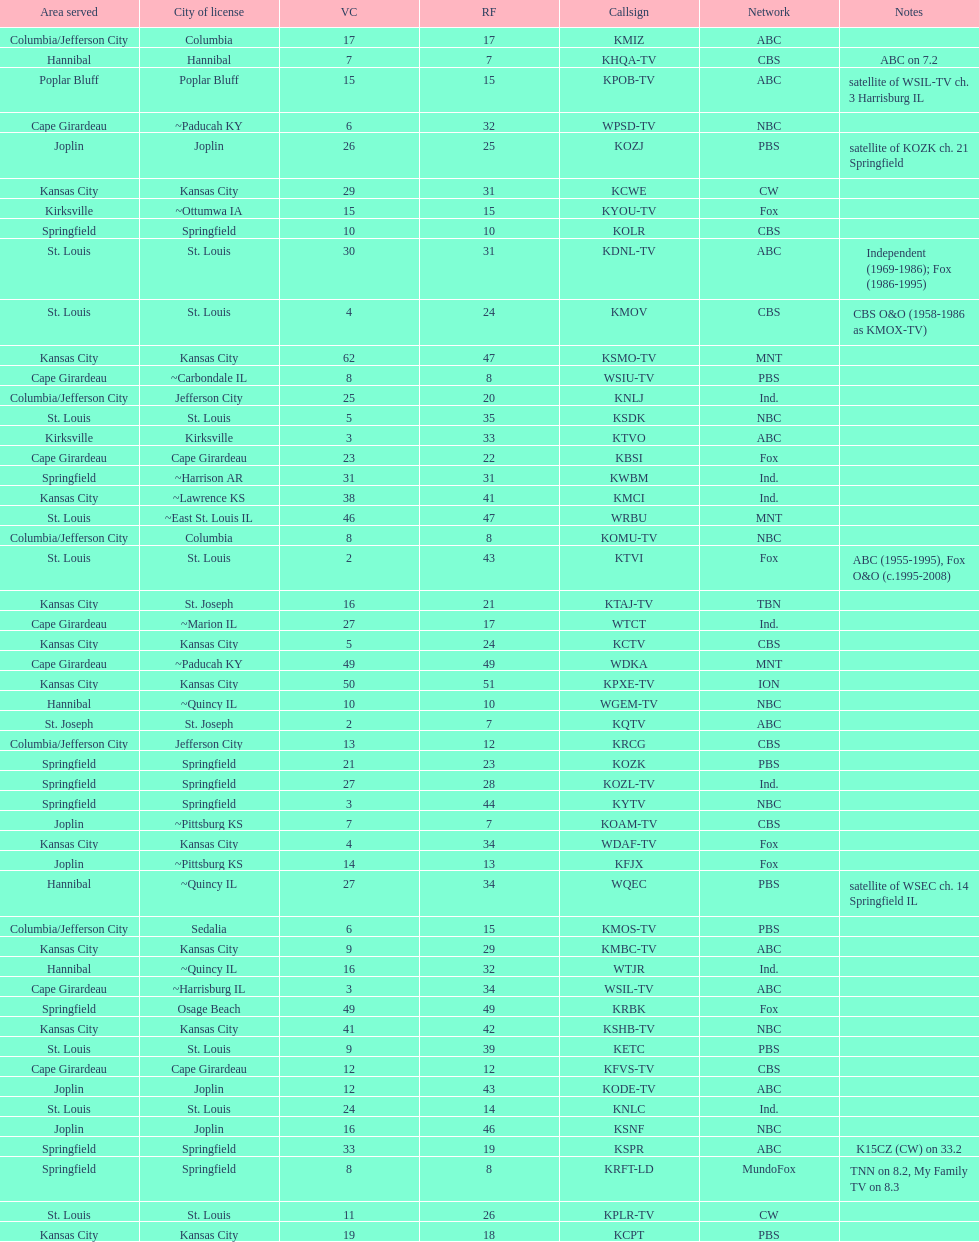What is the total number of stations serving the the cape girardeau area? 7. 